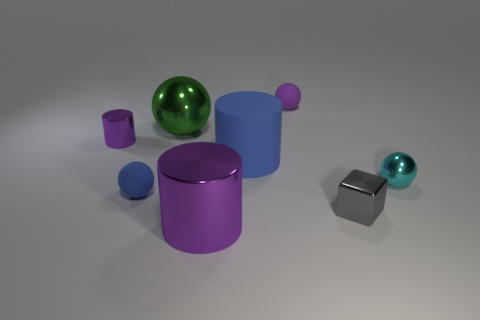How does the light in the scene affect the colors and the mood? The soft lighting in the scene casts gentle shadows and highlights on the objects, vividly bringing out the reflective surfaces, especially on the shiny gray cube and the greenish sphere. It gives a calm and serene mood, perfect for emphasizing the texture and depth of the objects. 